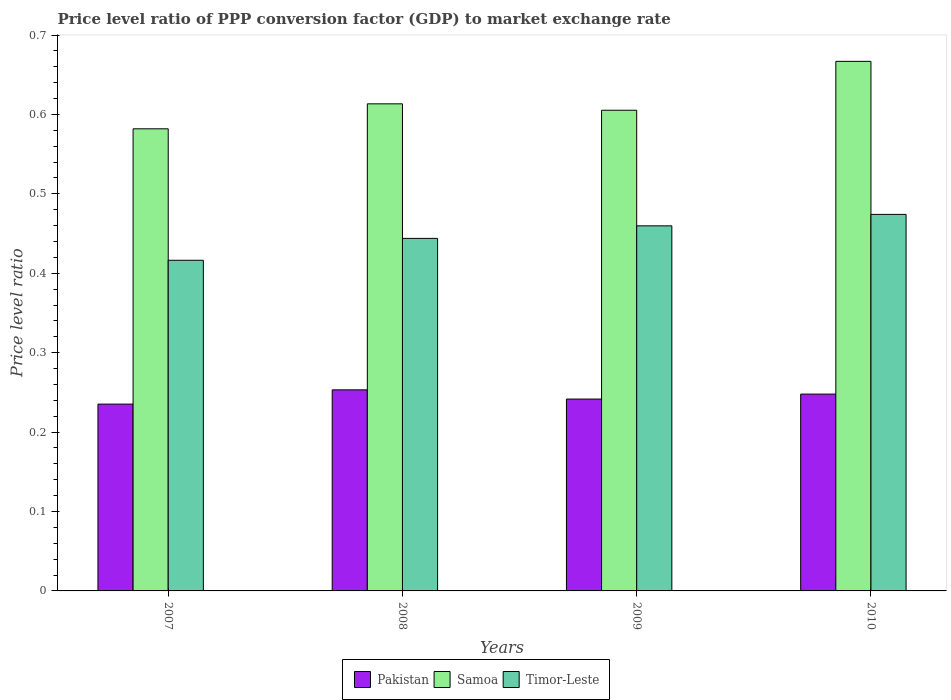What is the label of the 4th group of bars from the left?
Offer a very short reply. 2010. In how many cases, is the number of bars for a given year not equal to the number of legend labels?
Keep it short and to the point. 0. What is the price level ratio in Timor-Leste in 2010?
Give a very brief answer. 0.47. Across all years, what is the maximum price level ratio in Samoa?
Offer a very short reply. 0.67. Across all years, what is the minimum price level ratio in Pakistan?
Offer a very short reply. 0.24. In which year was the price level ratio in Samoa minimum?
Ensure brevity in your answer.  2007. What is the total price level ratio in Timor-Leste in the graph?
Make the answer very short. 1.79. What is the difference between the price level ratio in Timor-Leste in 2007 and that in 2009?
Your response must be concise. -0.04. What is the difference between the price level ratio in Pakistan in 2008 and the price level ratio in Timor-Leste in 2009?
Offer a terse response. -0.21. What is the average price level ratio in Pakistan per year?
Make the answer very short. 0.24. In the year 2010, what is the difference between the price level ratio in Samoa and price level ratio in Timor-Leste?
Provide a short and direct response. 0.19. In how many years, is the price level ratio in Samoa greater than 0.6600000000000001?
Your answer should be compact. 1. What is the ratio of the price level ratio in Timor-Leste in 2007 to that in 2009?
Keep it short and to the point. 0.91. What is the difference between the highest and the second highest price level ratio in Samoa?
Provide a succinct answer. 0.05. What is the difference between the highest and the lowest price level ratio in Timor-Leste?
Provide a succinct answer. 0.06. Is the sum of the price level ratio in Samoa in 2007 and 2009 greater than the maximum price level ratio in Timor-Leste across all years?
Provide a succinct answer. Yes. What does the 3rd bar from the left in 2009 represents?
Give a very brief answer. Timor-Leste. How many bars are there?
Your response must be concise. 12. Are all the bars in the graph horizontal?
Your response must be concise. No. How many years are there in the graph?
Make the answer very short. 4. What is the difference between two consecutive major ticks on the Y-axis?
Make the answer very short. 0.1. Are the values on the major ticks of Y-axis written in scientific E-notation?
Your response must be concise. No. Does the graph contain any zero values?
Your answer should be very brief. No. How many legend labels are there?
Your answer should be compact. 3. How are the legend labels stacked?
Make the answer very short. Horizontal. What is the title of the graph?
Your answer should be compact. Price level ratio of PPP conversion factor (GDP) to market exchange rate. What is the label or title of the Y-axis?
Ensure brevity in your answer.  Price level ratio. What is the Price level ratio in Pakistan in 2007?
Offer a very short reply. 0.24. What is the Price level ratio in Samoa in 2007?
Ensure brevity in your answer.  0.58. What is the Price level ratio in Timor-Leste in 2007?
Provide a short and direct response. 0.42. What is the Price level ratio of Pakistan in 2008?
Offer a very short reply. 0.25. What is the Price level ratio of Samoa in 2008?
Your answer should be very brief. 0.61. What is the Price level ratio of Timor-Leste in 2008?
Offer a terse response. 0.44. What is the Price level ratio in Pakistan in 2009?
Your response must be concise. 0.24. What is the Price level ratio in Samoa in 2009?
Keep it short and to the point. 0.61. What is the Price level ratio in Timor-Leste in 2009?
Make the answer very short. 0.46. What is the Price level ratio in Pakistan in 2010?
Keep it short and to the point. 0.25. What is the Price level ratio in Samoa in 2010?
Offer a terse response. 0.67. What is the Price level ratio of Timor-Leste in 2010?
Offer a very short reply. 0.47. Across all years, what is the maximum Price level ratio in Pakistan?
Give a very brief answer. 0.25. Across all years, what is the maximum Price level ratio of Samoa?
Your response must be concise. 0.67. Across all years, what is the maximum Price level ratio of Timor-Leste?
Ensure brevity in your answer.  0.47. Across all years, what is the minimum Price level ratio of Pakistan?
Your answer should be very brief. 0.24. Across all years, what is the minimum Price level ratio in Samoa?
Your answer should be compact. 0.58. Across all years, what is the minimum Price level ratio of Timor-Leste?
Your answer should be very brief. 0.42. What is the total Price level ratio of Pakistan in the graph?
Give a very brief answer. 0.98. What is the total Price level ratio in Samoa in the graph?
Provide a short and direct response. 2.47. What is the total Price level ratio in Timor-Leste in the graph?
Your answer should be compact. 1.79. What is the difference between the Price level ratio in Pakistan in 2007 and that in 2008?
Your answer should be compact. -0.02. What is the difference between the Price level ratio of Samoa in 2007 and that in 2008?
Your answer should be very brief. -0.03. What is the difference between the Price level ratio of Timor-Leste in 2007 and that in 2008?
Give a very brief answer. -0.03. What is the difference between the Price level ratio of Pakistan in 2007 and that in 2009?
Offer a terse response. -0.01. What is the difference between the Price level ratio of Samoa in 2007 and that in 2009?
Provide a short and direct response. -0.02. What is the difference between the Price level ratio of Timor-Leste in 2007 and that in 2009?
Make the answer very short. -0.04. What is the difference between the Price level ratio of Pakistan in 2007 and that in 2010?
Your response must be concise. -0.01. What is the difference between the Price level ratio in Samoa in 2007 and that in 2010?
Your answer should be compact. -0.08. What is the difference between the Price level ratio of Timor-Leste in 2007 and that in 2010?
Give a very brief answer. -0.06. What is the difference between the Price level ratio in Pakistan in 2008 and that in 2009?
Your answer should be very brief. 0.01. What is the difference between the Price level ratio in Samoa in 2008 and that in 2009?
Make the answer very short. 0.01. What is the difference between the Price level ratio in Timor-Leste in 2008 and that in 2009?
Keep it short and to the point. -0.02. What is the difference between the Price level ratio of Pakistan in 2008 and that in 2010?
Offer a very short reply. 0.01. What is the difference between the Price level ratio in Samoa in 2008 and that in 2010?
Your answer should be very brief. -0.05. What is the difference between the Price level ratio in Timor-Leste in 2008 and that in 2010?
Give a very brief answer. -0.03. What is the difference between the Price level ratio of Pakistan in 2009 and that in 2010?
Ensure brevity in your answer.  -0.01. What is the difference between the Price level ratio of Samoa in 2009 and that in 2010?
Your answer should be compact. -0.06. What is the difference between the Price level ratio in Timor-Leste in 2009 and that in 2010?
Ensure brevity in your answer.  -0.01. What is the difference between the Price level ratio in Pakistan in 2007 and the Price level ratio in Samoa in 2008?
Make the answer very short. -0.38. What is the difference between the Price level ratio in Pakistan in 2007 and the Price level ratio in Timor-Leste in 2008?
Provide a succinct answer. -0.21. What is the difference between the Price level ratio in Samoa in 2007 and the Price level ratio in Timor-Leste in 2008?
Keep it short and to the point. 0.14. What is the difference between the Price level ratio of Pakistan in 2007 and the Price level ratio of Samoa in 2009?
Offer a terse response. -0.37. What is the difference between the Price level ratio in Pakistan in 2007 and the Price level ratio in Timor-Leste in 2009?
Provide a short and direct response. -0.22. What is the difference between the Price level ratio of Samoa in 2007 and the Price level ratio of Timor-Leste in 2009?
Make the answer very short. 0.12. What is the difference between the Price level ratio of Pakistan in 2007 and the Price level ratio of Samoa in 2010?
Your response must be concise. -0.43. What is the difference between the Price level ratio of Pakistan in 2007 and the Price level ratio of Timor-Leste in 2010?
Ensure brevity in your answer.  -0.24. What is the difference between the Price level ratio in Samoa in 2007 and the Price level ratio in Timor-Leste in 2010?
Ensure brevity in your answer.  0.11. What is the difference between the Price level ratio of Pakistan in 2008 and the Price level ratio of Samoa in 2009?
Give a very brief answer. -0.35. What is the difference between the Price level ratio of Pakistan in 2008 and the Price level ratio of Timor-Leste in 2009?
Make the answer very short. -0.21. What is the difference between the Price level ratio in Samoa in 2008 and the Price level ratio in Timor-Leste in 2009?
Your answer should be compact. 0.15. What is the difference between the Price level ratio in Pakistan in 2008 and the Price level ratio in Samoa in 2010?
Your answer should be very brief. -0.41. What is the difference between the Price level ratio in Pakistan in 2008 and the Price level ratio in Timor-Leste in 2010?
Make the answer very short. -0.22. What is the difference between the Price level ratio of Samoa in 2008 and the Price level ratio of Timor-Leste in 2010?
Offer a very short reply. 0.14. What is the difference between the Price level ratio of Pakistan in 2009 and the Price level ratio of Samoa in 2010?
Make the answer very short. -0.43. What is the difference between the Price level ratio of Pakistan in 2009 and the Price level ratio of Timor-Leste in 2010?
Your answer should be very brief. -0.23. What is the difference between the Price level ratio in Samoa in 2009 and the Price level ratio in Timor-Leste in 2010?
Ensure brevity in your answer.  0.13. What is the average Price level ratio of Pakistan per year?
Provide a succinct answer. 0.24. What is the average Price level ratio in Samoa per year?
Keep it short and to the point. 0.62. What is the average Price level ratio in Timor-Leste per year?
Offer a terse response. 0.45. In the year 2007, what is the difference between the Price level ratio in Pakistan and Price level ratio in Samoa?
Provide a succinct answer. -0.35. In the year 2007, what is the difference between the Price level ratio of Pakistan and Price level ratio of Timor-Leste?
Ensure brevity in your answer.  -0.18. In the year 2007, what is the difference between the Price level ratio in Samoa and Price level ratio in Timor-Leste?
Give a very brief answer. 0.17. In the year 2008, what is the difference between the Price level ratio of Pakistan and Price level ratio of Samoa?
Offer a very short reply. -0.36. In the year 2008, what is the difference between the Price level ratio in Pakistan and Price level ratio in Timor-Leste?
Provide a succinct answer. -0.19. In the year 2008, what is the difference between the Price level ratio of Samoa and Price level ratio of Timor-Leste?
Your response must be concise. 0.17. In the year 2009, what is the difference between the Price level ratio in Pakistan and Price level ratio in Samoa?
Keep it short and to the point. -0.36. In the year 2009, what is the difference between the Price level ratio of Pakistan and Price level ratio of Timor-Leste?
Your response must be concise. -0.22. In the year 2009, what is the difference between the Price level ratio in Samoa and Price level ratio in Timor-Leste?
Your answer should be very brief. 0.15. In the year 2010, what is the difference between the Price level ratio of Pakistan and Price level ratio of Samoa?
Provide a succinct answer. -0.42. In the year 2010, what is the difference between the Price level ratio in Pakistan and Price level ratio in Timor-Leste?
Keep it short and to the point. -0.23. In the year 2010, what is the difference between the Price level ratio of Samoa and Price level ratio of Timor-Leste?
Provide a succinct answer. 0.19. What is the ratio of the Price level ratio of Pakistan in 2007 to that in 2008?
Your answer should be very brief. 0.93. What is the ratio of the Price level ratio in Samoa in 2007 to that in 2008?
Your answer should be very brief. 0.95. What is the ratio of the Price level ratio of Timor-Leste in 2007 to that in 2008?
Make the answer very short. 0.94. What is the ratio of the Price level ratio of Pakistan in 2007 to that in 2009?
Provide a short and direct response. 0.97. What is the ratio of the Price level ratio of Samoa in 2007 to that in 2009?
Give a very brief answer. 0.96. What is the ratio of the Price level ratio of Timor-Leste in 2007 to that in 2009?
Give a very brief answer. 0.91. What is the ratio of the Price level ratio of Pakistan in 2007 to that in 2010?
Make the answer very short. 0.95. What is the ratio of the Price level ratio of Samoa in 2007 to that in 2010?
Make the answer very short. 0.87. What is the ratio of the Price level ratio of Timor-Leste in 2007 to that in 2010?
Your response must be concise. 0.88. What is the ratio of the Price level ratio of Pakistan in 2008 to that in 2009?
Offer a very short reply. 1.05. What is the ratio of the Price level ratio in Samoa in 2008 to that in 2009?
Your response must be concise. 1.01. What is the ratio of the Price level ratio in Timor-Leste in 2008 to that in 2009?
Your response must be concise. 0.97. What is the ratio of the Price level ratio of Pakistan in 2008 to that in 2010?
Provide a succinct answer. 1.02. What is the ratio of the Price level ratio in Samoa in 2008 to that in 2010?
Keep it short and to the point. 0.92. What is the ratio of the Price level ratio of Timor-Leste in 2008 to that in 2010?
Offer a very short reply. 0.94. What is the ratio of the Price level ratio in Pakistan in 2009 to that in 2010?
Provide a succinct answer. 0.97. What is the ratio of the Price level ratio in Samoa in 2009 to that in 2010?
Your response must be concise. 0.91. What is the ratio of the Price level ratio in Timor-Leste in 2009 to that in 2010?
Your answer should be very brief. 0.97. What is the difference between the highest and the second highest Price level ratio in Pakistan?
Give a very brief answer. 0.01. What is the difference between the highest and the second highest Price level ratio in Samoa?
Offer a terse response. 0.05. What is the difference between the highest and the second highest Price level ratio in Timor-Leste?
Provide a succinct answer. 0.01. What is the difference between the highest and the lowest Price level ratio of Pakistan?
Provide a short and direct response. 0.02. What is the difference between the highest and the lowest Price level ratio of Samoa?
Offer a very short reply. 0.08. What is the difference between the highest and the lowest Price level ratio in Timor-Leste?
Ensure brevity in your answer.  0.06. 